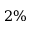Convert formula to latex. <formula><loc_0><loc_0><loc_500><loc_500>2 \%</formula> 